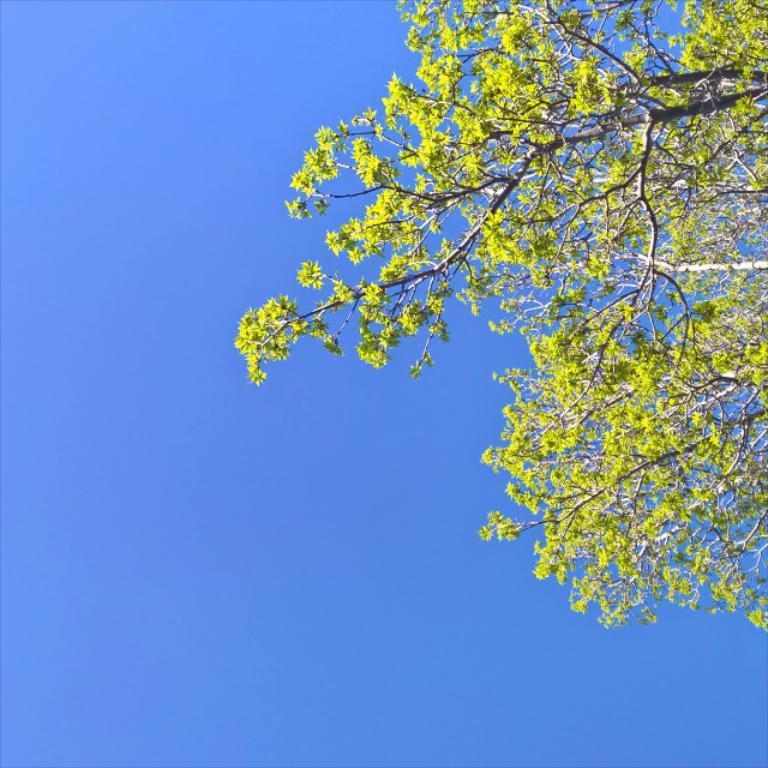Can you describe this image briefly? In this image I can see a tree and few flowers to the tree which are yellow in color. In the background I can see the sky which is blue in color. 